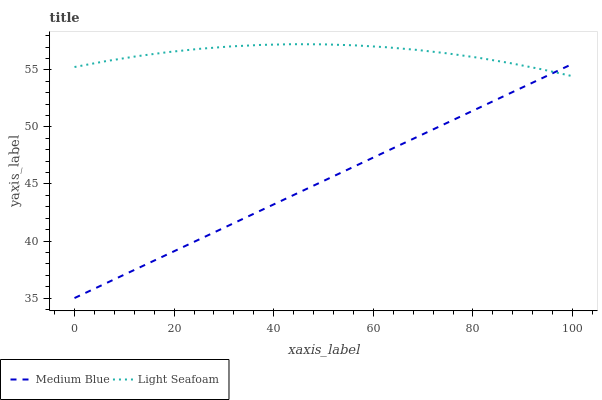Does Medium Blue have the minimum area under the curve?
Answer yes or no. Yes. Does Light Seafoam have the maximum area under the curve?
Answer yes or no. Yes. Does Medium Blue have the maximum area under the curve?
Answer yes or no. No. Is Medium Blue the smoothest?
Answer yes or no. Yes. Is Light Seafoam the roughest?
Answer yes or no. Yes. Is Medium Blue the roughest?
Answer yes or no. No. Does Medium Blue have the lowest value?
Answer yes or no. Yes. Does Light Seafoam have the highest value?
Answer yes or no. Yes. Does Medium Blue have the highest value?
Answer yes or no. No. Does Light Seafoam intersect Medium Blue?
Answer yes or no. Yes. Is Light Seafoam less than Medium Blue?
Answer yes or no. No. Is Light Seafoam greater than Medium Blue?
Answer yes or no. No. 